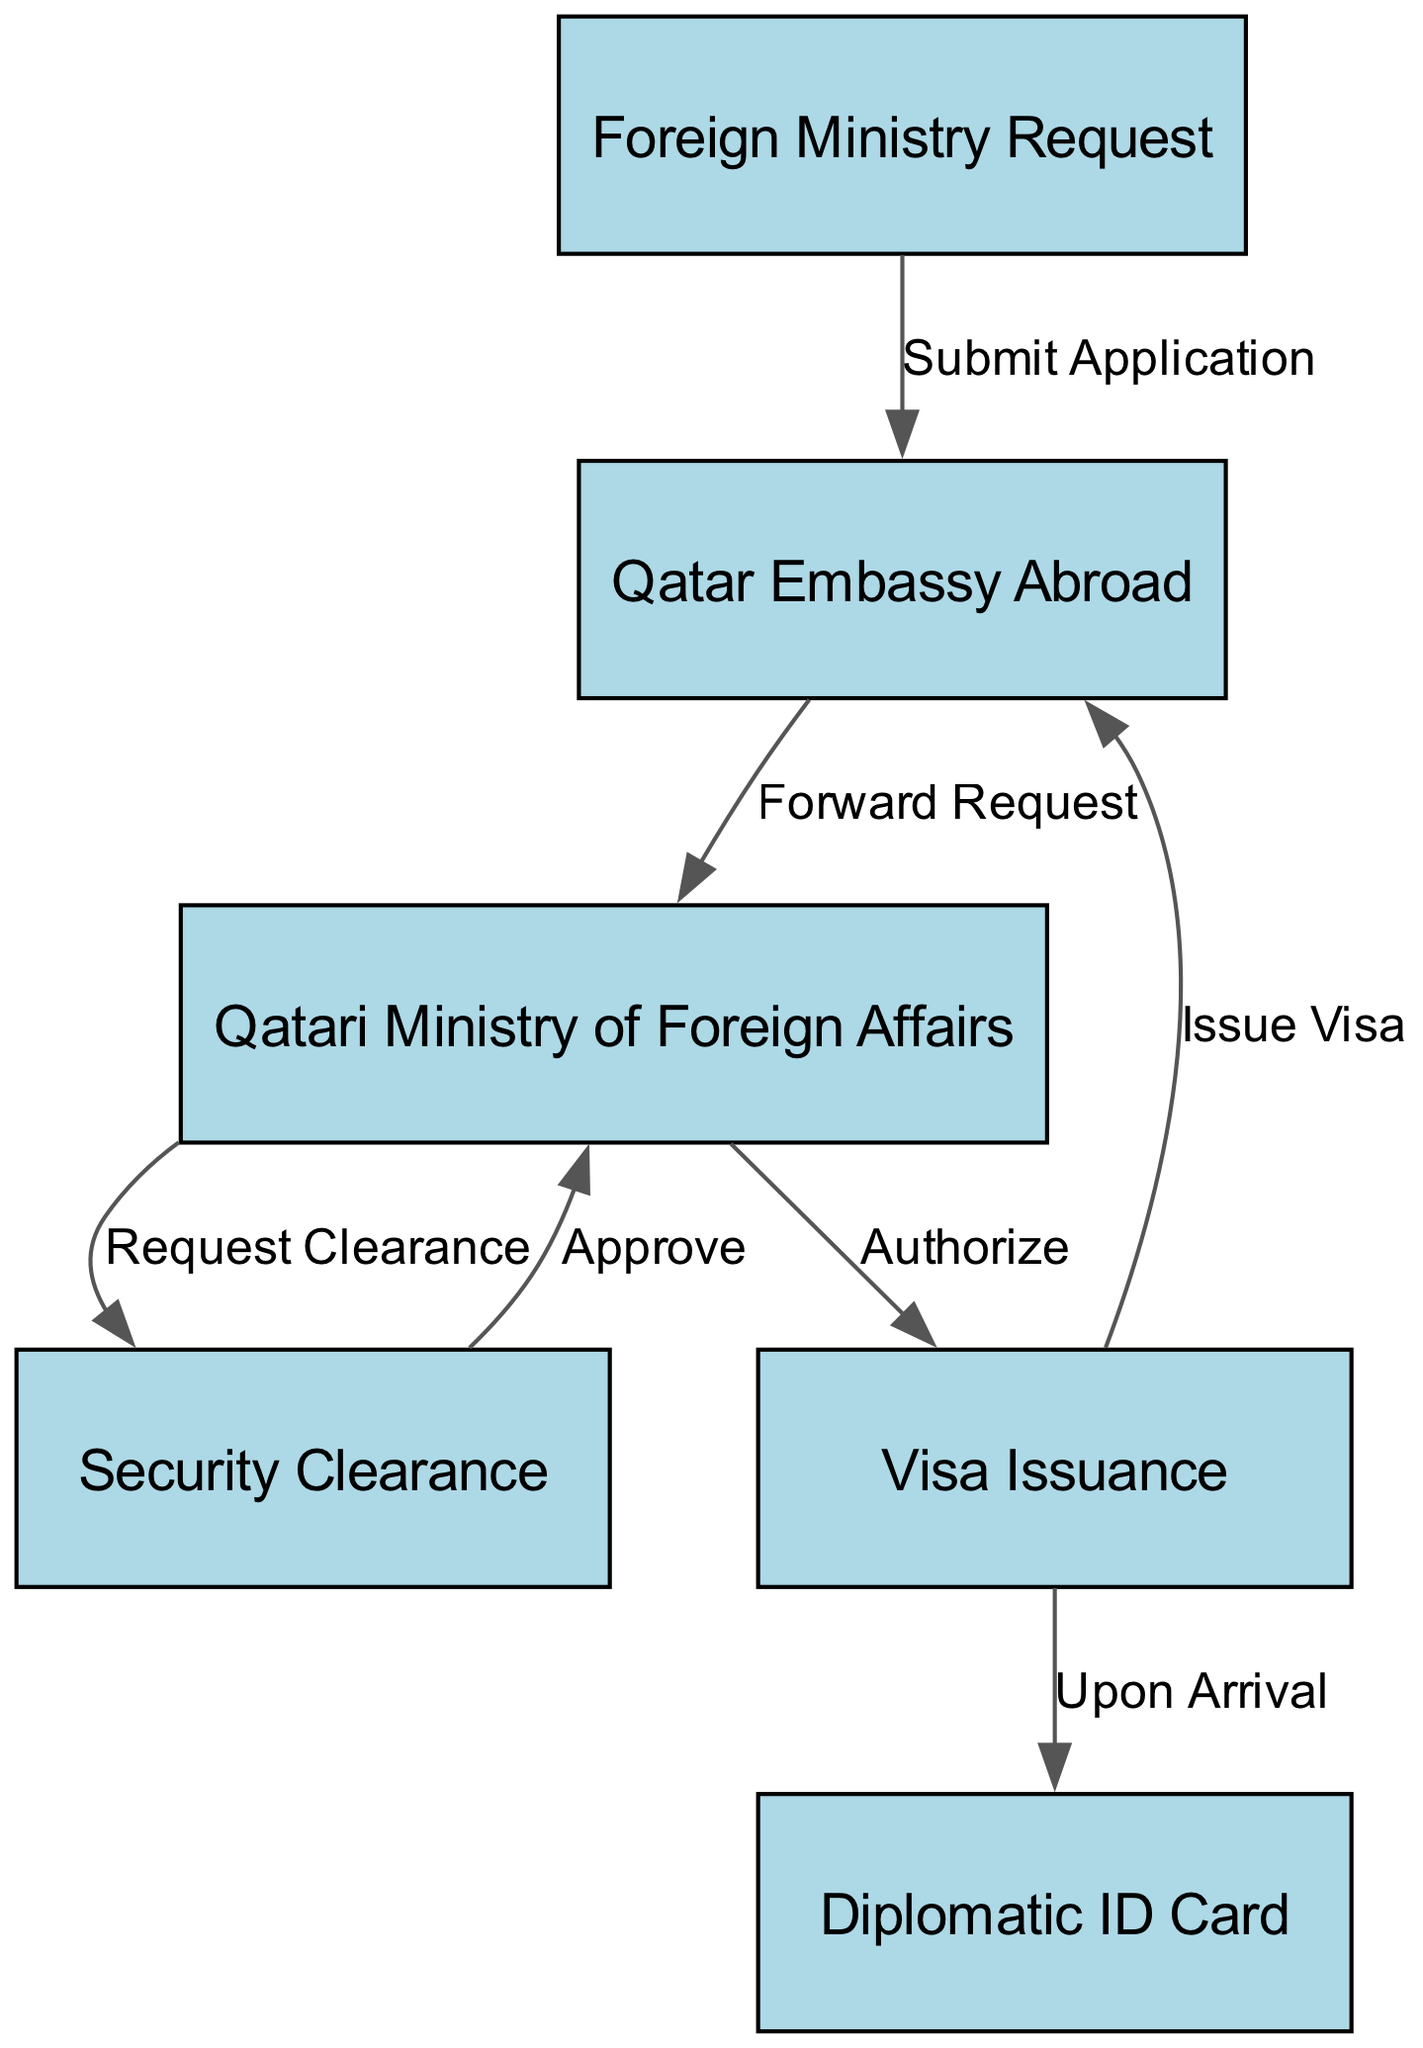What is the first step in the visa application process? The first step in the diagram is labeled "Foreign Ministry Request," indicating that the initial action is to submit a request by the foreign ministry.
Answer: Foreign Ministry Request How many nodes are present in the diagram? The diagram features six nodes, each representing a different stage in the visa application and approval process.
Answer: 6 What does the Qatar Embassy Abroad do with the application? The label on the edge from "Qatar Embassy Abroad" to "Qatari Ministry of Foreign Affairs" states "Forward Request," indicating that the embassy forwards the application to the ministry.
Answer: Forward Request Which node comes after Security Clearance? The "Visa Issuance" node follows the "Security Clearance" node, as shown by the directed edge connecting them.
Answer: Visa Issuance What is issued upon arrival in Qatar? According to the edge from the "Visa Issuance" node to "Diplomatic ID Card," the issuance of the ID card occurs upon the diplomat's arrival in Qatar.
Answer: Diplomatic ID Card How is the visa issued after approval? The diagram indicates that following the authorized request from the "Qatari Ministry of Foreign Affairs," the visa is issued as represented by the edge leading from the "Visa Issuance" node back to the "Qatar Embassy Abroad."
Answer: Issue Visa Which nodes are involved in the security clearance process? The "Qatari Ministry of Foreign Affairs" requests security clearance from the "Security Clearance" node, which then communicates back approval to the ministry. This interaction involves both nodes.
Answer: Qatari Ministry of Foreign Affairs, Security Clearance What label describes the action taken by the Qatari Ministry of Foreign Affairs to the Security Clearance? The edge from "Qatari Ministry of Foreign Affairs" to "Security Clearance" is labeled "Request Clearance," indicating the action taken in this step of the process.
Answer: Request Clearance What is the final outcome of the overall process depicted in the diagram? The diagram illustrates that the final outcome is the issuance of a "Diplomatic ID Card" after the visa is issued upon the diplomat’s arrival in Qatar.
Answer: Diplomatic ID Card 